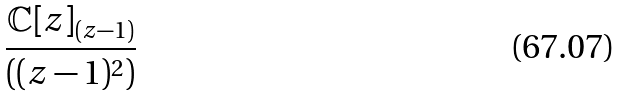<formula> <loc_0><loc_0><loc_500><loc_500>\frac { \mathbb { C } [ z ] _ { ( z - 1 ) } } { ( ( z - 1 ) ^ { 2 } ) }</formula> 